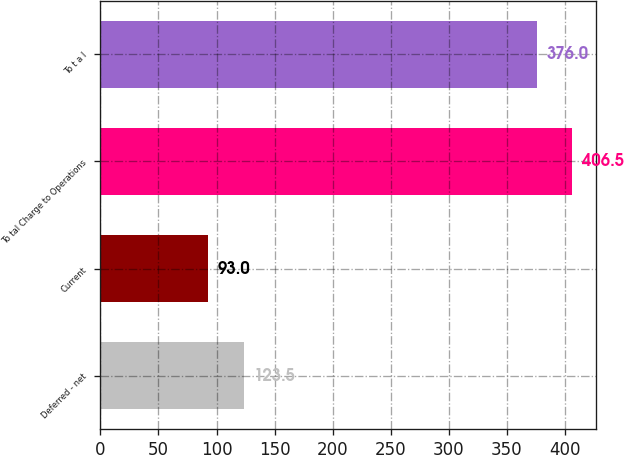Convert chart to OTSL. <chart><loc_0><loc_0><loc_500><loc_500><bar_chart><fcel>Deferred - net<fcel>Current<fcel>To tal Charge to Operations<fcel>To t a l<nl><fcel>123.5<fcel>93<fcel>406.5<fcel>376<nl></chart> 